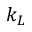<formula> <loc_0><loc_0><loc_500><loc_500>k _ { L }</formula> 